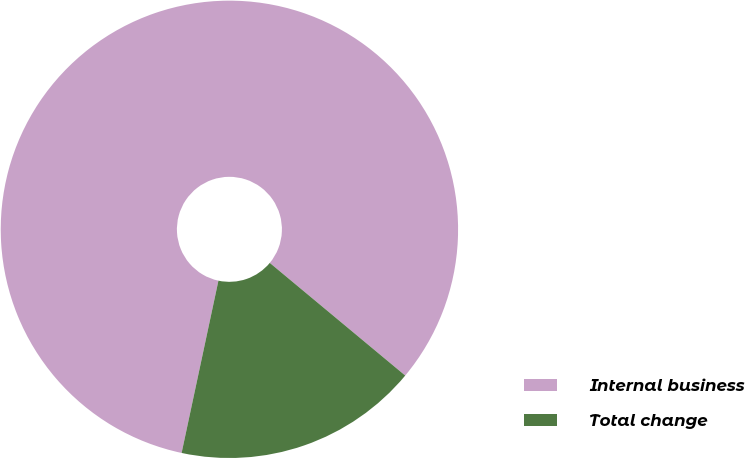Convert chart to OTSL. <chart><loc_0><loc_0><loc_500><loc_500><pie_chart><fcel>Internal business<fcel>Total change<nl><fcel>82.69%<fcel>17.31%<nl></chart> 